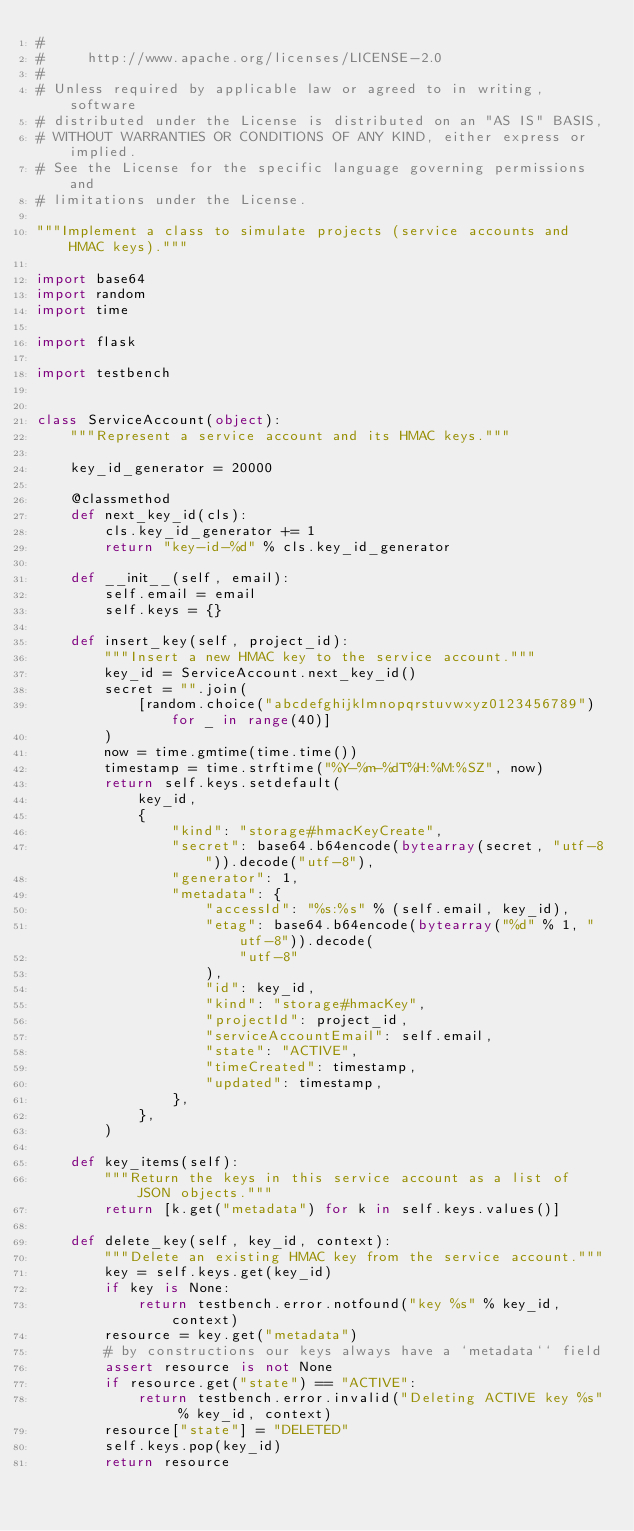Convert code to text. <code><loc_0><loc_0><loc_500><loc_500><_Python_>#
#     http://www.apache.org/licenses/LICENSE-2.0
#
# Unless required by applicable law or agreed to in writing, software
# distributed under the License is distributed on an "AS IS" BASIS,
# WITHOUT WARRANTIES OR CONDITIONS OF ANY KIND, either express or implied.
# See the License for the specific language governing permissions and
# limitations under the License.

"""Implement a class to simulate projects (service accounts and HMAC keys)."""

import base64
import random
import time

import flask

import testbench


class ServiceAccount(object):
    """Represent a service account and its HMAC keys."""

    key_id_generator = 20000

    @classmethod
    def next_key_id(cls):
        cls.key_id_generator += 1
        return "key-id-%d" % cls.key_id_generator

    def __init__(self, email):
        self.email = email
        self.keys = {}

    def insert_key(self, project_id):
        """Insert a new HMAC key to the service account."""
        key_id = ServiceAccount.next_key_id()
        secret = "".join(
            [random.choice("abcdefghijklmnopqrstuvwxyz0123456789") for _ in range(40)]
        )
        now = time.gmtime(time.time())
        timestamp = time.strftime("%Y-%m-%dT%H:%M:%SZ", now)
        return self.keys.setdefault(
            key_id,
            {
                "kind": "storage#hmacKeyCreate",
                "secret": base64.b64encode(bytearray(secret, "utf-8")).decode("utf-8"),
                "generator": 1,
                "metadata": {
                    "accessId": "%s:%s" % (self.email, key_id),
                    "etag": base64.b64encode(bytearray("%d" % 1, "utf-8")).decode(
                        "utf-8"
                    ),
                    "id": key_id,
                    "kind": "storage#hmacKey",
                    "projectId": project_id,
                    "serviceAccountEmail": self.email,
                    "state": "ACTIVE",
                    "timeCreated": timestamp,
                    "updated": timestamp,
                },
            },
        )

    def key_items(self):
        """Return the keys in this service account as a list of JSON objects."""
        return [k.get("metadata") for k in self.keys.values()]

    def delete_key(self, key_id, context):
        """Delete an existing HMAC key from the service account."""
        key = self.keys.get(key_id)
        if key is None:
            return testbench.error.notfound("key %s" % key_id, context)
        resource = key.get("metadata")
        # by constructions our keys always have a `metadata`` field
        assert resource is not None
        if resource.get("state") == "ACTIVE":
            return testbench.error.invalid("Deleting ACTIVE key %s" % key_id, context)
        resource["state"] = "DELETED"
        self.keys.pop(key_id)
        return resource
</code> 